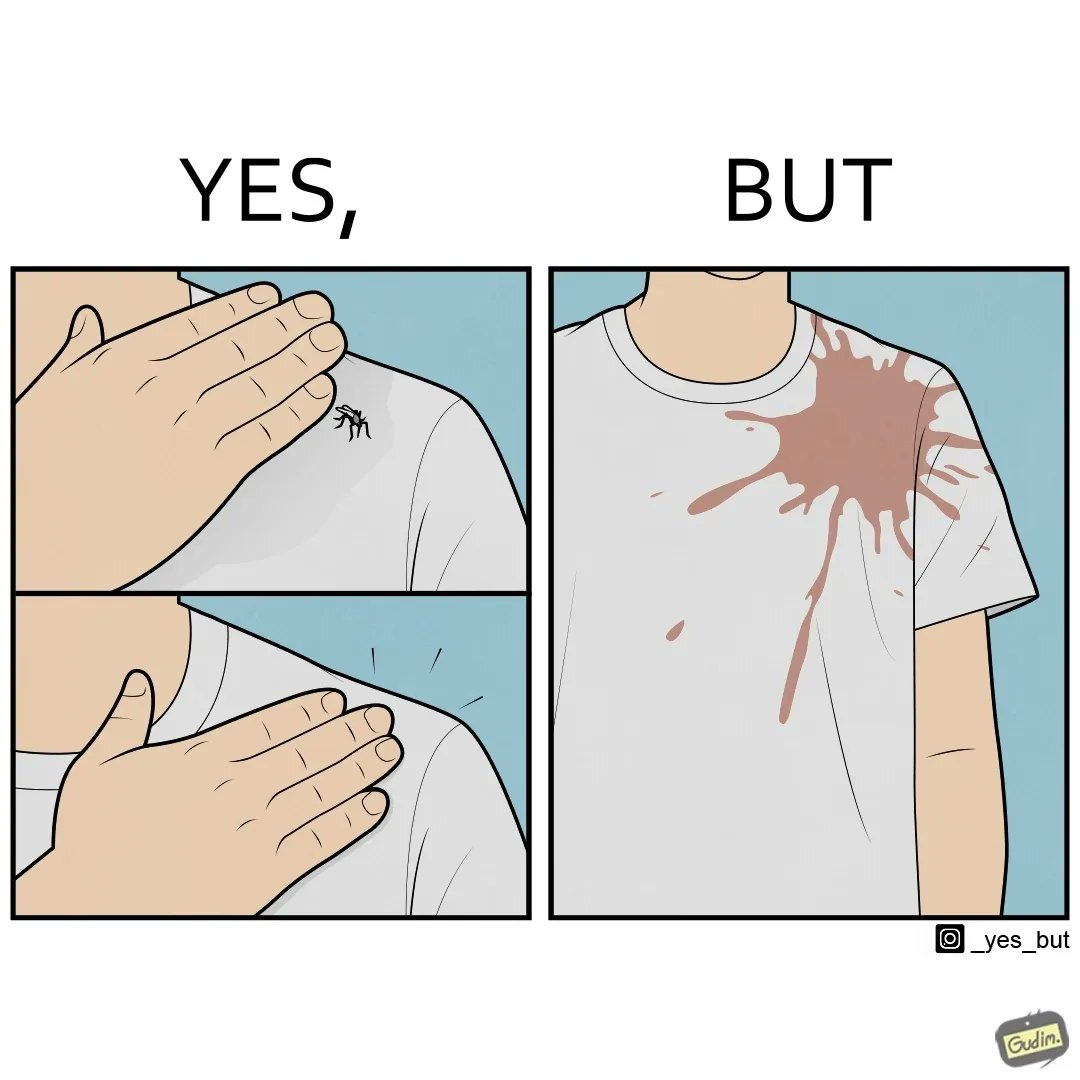Is there satirical content in this image? Yes, this image is satirical. 